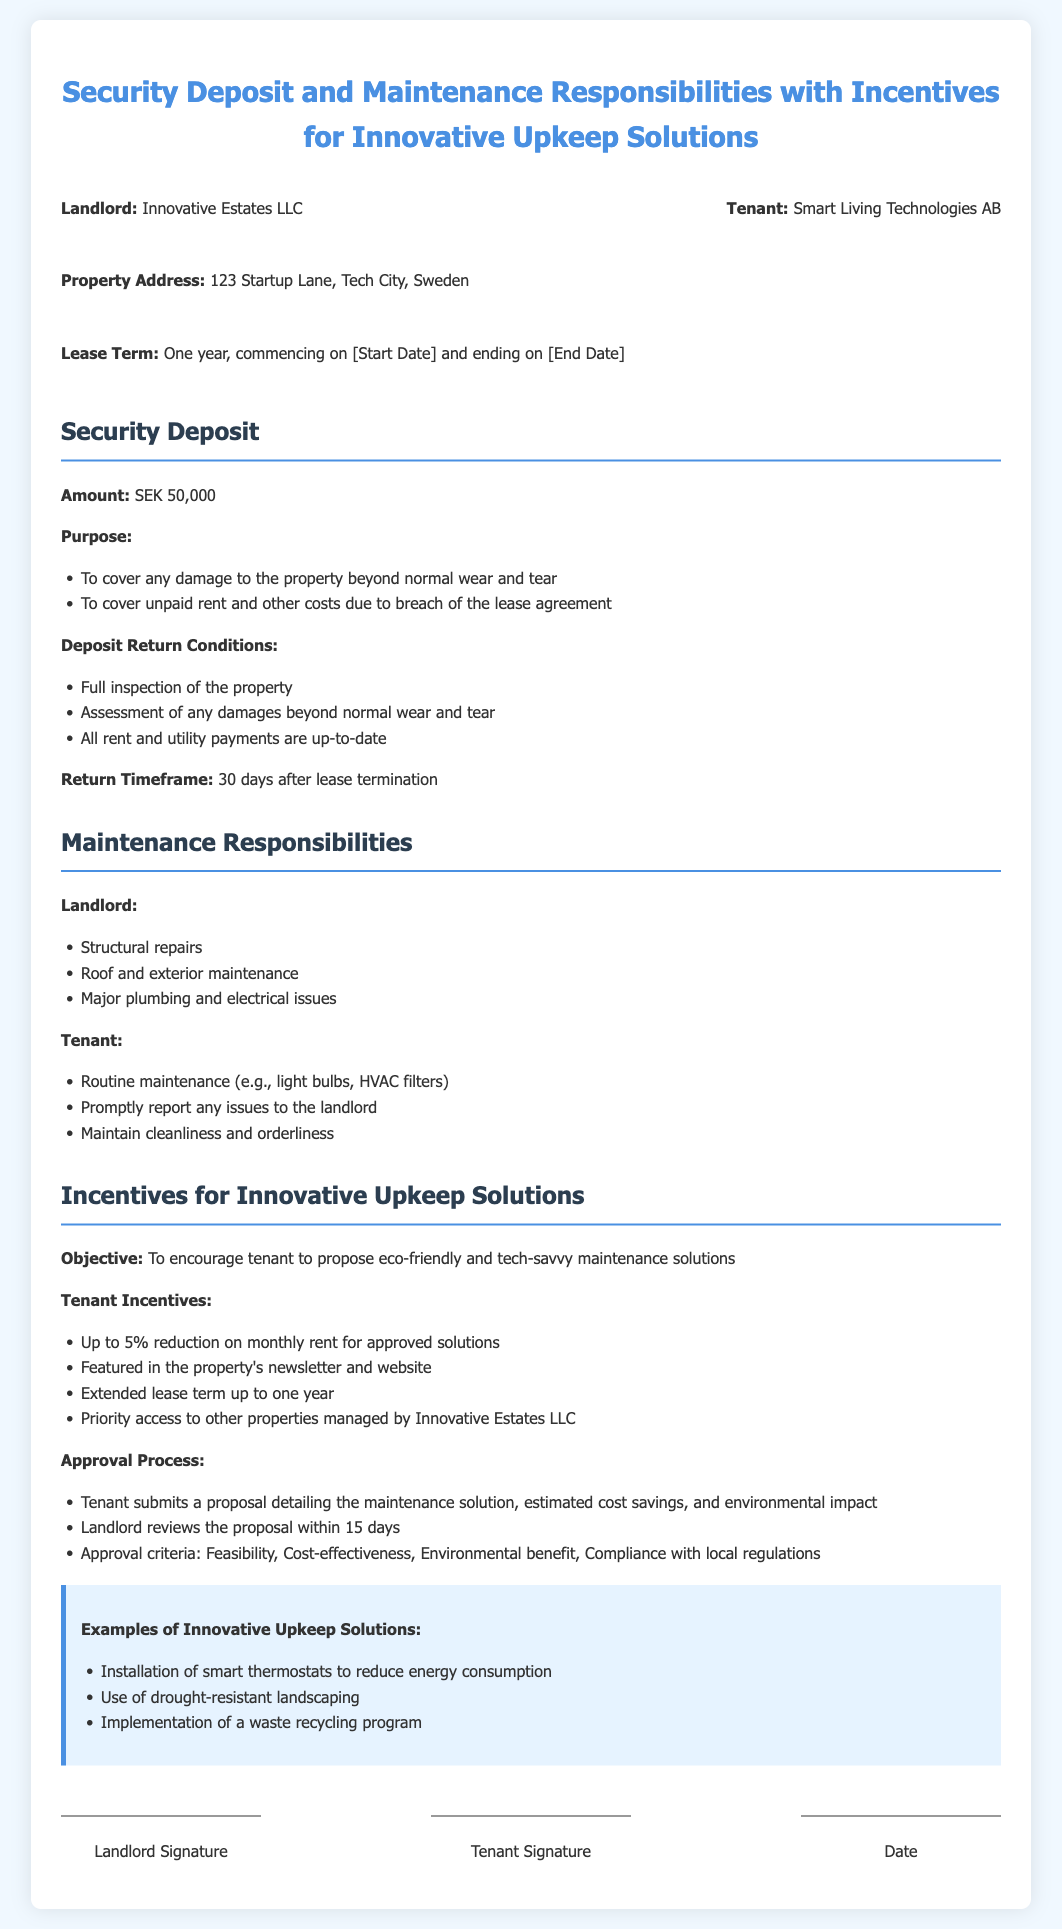What is the security deposit amount? The document specifies the security deposit amount, which is clearly listed under the Security Deposit section.
Answer: SEK 50,000 What are the conditions for the return of the deposit? The return conditions are outlined in a list under the Security Deposit section, detailing what needs to be fulfilled for the deposit to be returned.
Answer: Full inspection, assessment of damages, all payments up-to-date Who is responsible for structural repairs? The Landlord's responsibilities are stated under the Maintenance Responsibilities section, identifying which repairs fall under their jurisdiction.
Answer: Landlord What percentage reduction in rent can the tenant receive for approved solutions? The document mentions an incentive structured in percentages for the tenant in the Incentives for Innovative Upkeep Solutions section.
Answer: Up to 5% What is the timeframe for deposit return after lease termination? The timeframe is specified in the Security Deposit section as a clear time period that must pass after lease end.
Answer: 30 days What type of maintenance is the tenant responsible for? The document outlines the tenant's responsibilities in the Maintenance Responsibilities section, listing routine tasks they must perform.
Answer: Routine maintenance How long is the lease term? The lease term is stated at the beginning of the document under the Lease Term section indicating its duration.
Answer: One year What is the landlord's company name? The name of the landlord's company is given at the start of the document, identifying who the landlord is.
Answer: Innovative Estates LLC What must a tenant do to propose an innovative maintenance solution? The document describes the process the tenant must follow to submit their proposal as stated in the Incentives for Innovative Upkeep Solutions section.
Answer: Submit a proposal detailing the solution 